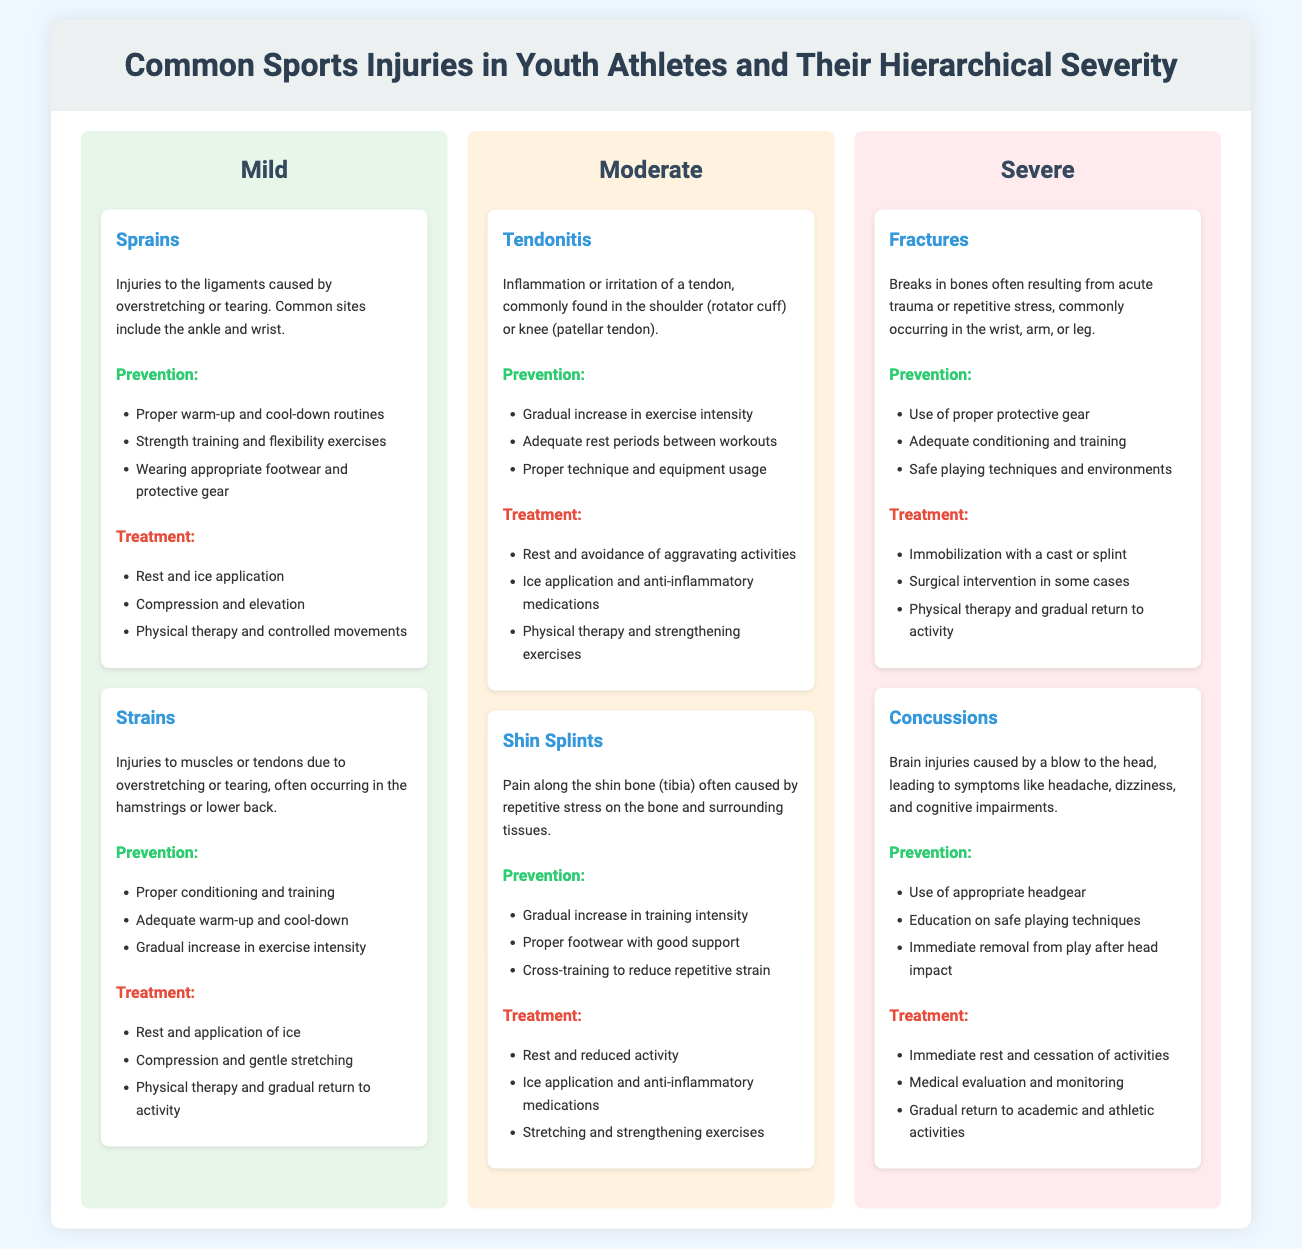What are the three severity levels? The document outlines three severity levels: Mild, Moderate, and Severe.
Answer: Mild, Moderate, Severe What is a common site for sprains? The document mentions the ankle and wrist as common sites for sprains.
Answer: Ankle and wrist What type of injury is tendonitis? Tendonitis is described as an inflammation or irritation of a tendon.
Answer: Inflammation or irritation of a tendon What is one prevention method for fractures? The document states that using proper protective gear is one method of prevention for fractures.
Answer: Use of proper protective gear What is a symptom of concussions? Symptoms of concussions include headache, dizziness, and cognitive impairments.
Answer: Headache, dizziness, cognitive impairments How many treatments are listed for shin splints? The document lists three treatments for shin splints: rest, ice application, and stretching exercises.
Answer: Three What are two examples of mild injuries? The document lists sprains and strains as examples of mild injuries.
Answer: Sprains, strains Which injury falls under the severe category? The document indicates fractures and concussions as injuries that fall under the severe category.
Answer: Fractures, concussions 